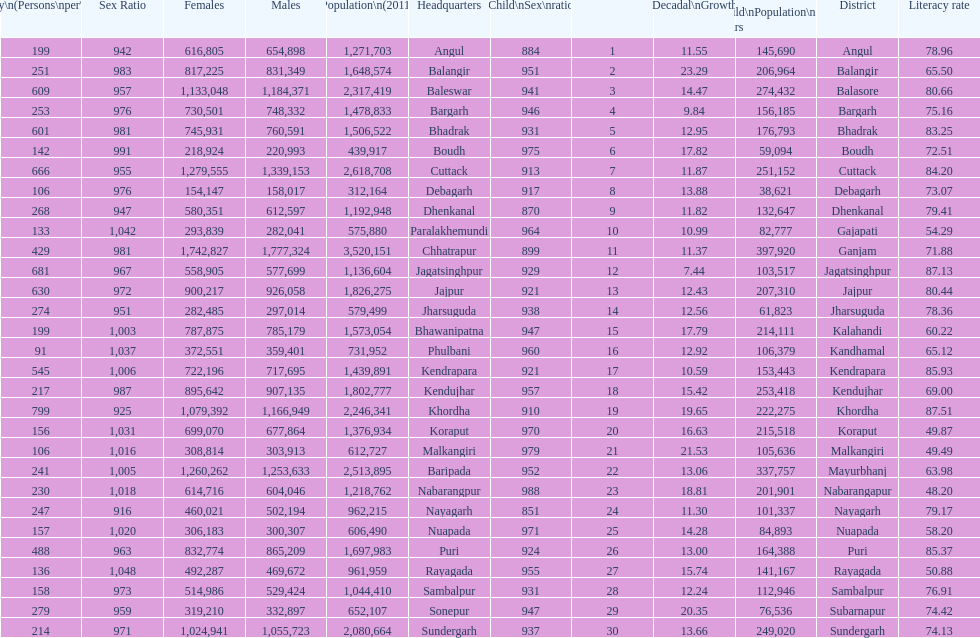Which district had the most people per km? Khordha. 